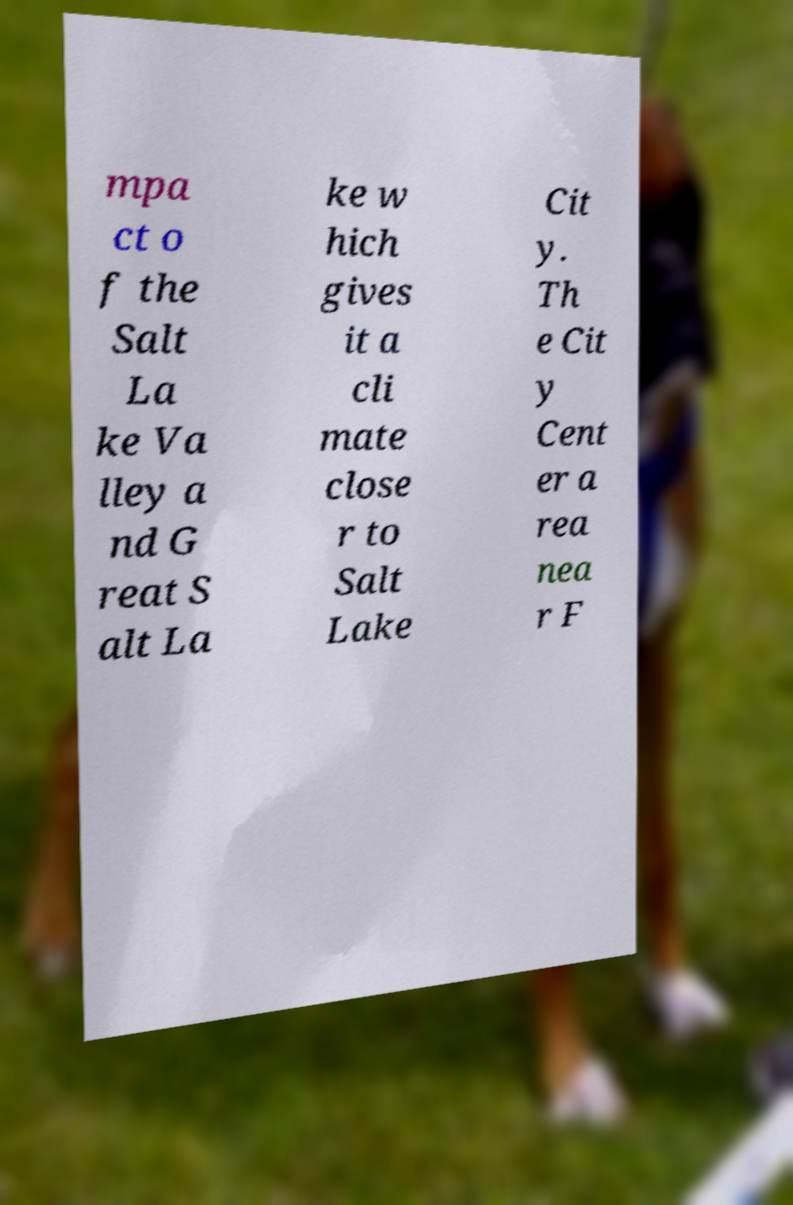I need the written content from this picture converted into text. Can you do that? mpa ct o f the Salt La ke Va lley a nd G reat S alt La ke w hich gives it a cli mate close r to Salt Lake Cit y. Th e Cit y Cent er a rea nea r F 